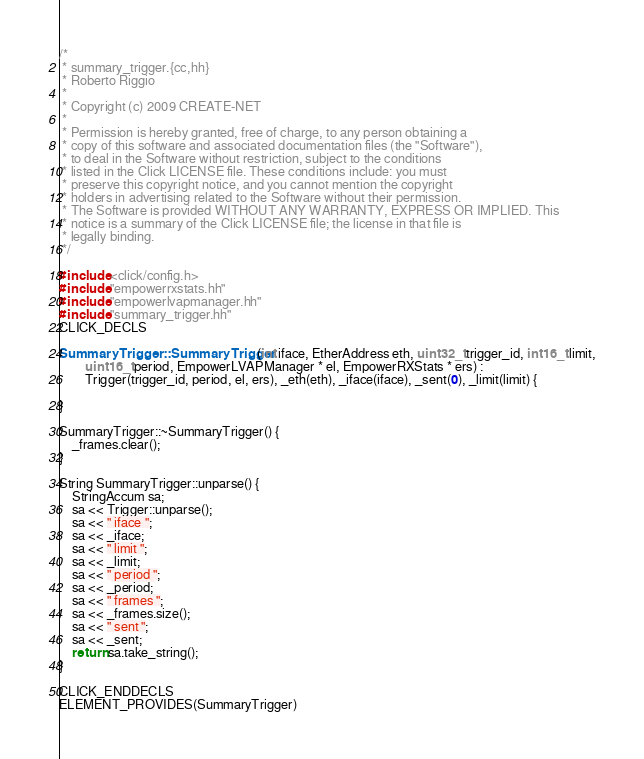Convert code to text. <code><loc_0><loc_0><loc_500><loc_500><_C++_>/*
 * summary_trigger.{cc,hh}
 * Roberto Riggio
 *
 * Copyright (c) 2009 CREATE-NET
 *
 * Permission is hereby granted, free of charge, to any person obtaining a
 * copy of this software and associated documentation files (the "Software"),
 * to deal in the Software without restriction, subject to the conditions
 * listed in the Click LICENSE file. These conditions include: you must
 * preserve this copyright notice, and you cannot mention the copyright
 * holders in advertising related to the Software without their permission.
 * The Software is provided WITHOUT ANY WARRANTY, EXPRESS OR IMPLIED. This
 * notice is a summary of the Click LICENSE file; the license in that file is
 * legally binding.
 */

#include <click/config.h>
#include "empowerrxstats.hh"
#include "empowerlvapmanager.hh"
#include "summary_trigger.hh"
CLICK_DECLS

SummaryTrigger::SummaryTrigger(int iface, EtherAddress eth, uint32_t trigger_id, int16_t limit,
		uint16_t period, EmpowerLVAPManager * el, EmpowerRXStats * ers) :
		Trigger(trigger_id, period, el, ers), _eth(eth), _iface(iface), _sent(0), _limit(limit) {

}

SummaryTrigger::~SummaryTrigger() {
	_frames.clear();
}

String SummaryTrigger::unparse() {
	StringAccum sa;
	sa << Trigger::unparse();
	sa << " iface ";
	sa << _iface;
	sa << " limit ";
	sa << _limit;
	sa << " period ";
	sa << _period;
	sa << " frames ";
	sa << _frames.size();
	sa << " sent ";
	sa << _sent;
	return sa.take_string();
}

CLICK_ENDDECLS
ELEMENT_PROVIDES(SummaryTrigger)

</code> 